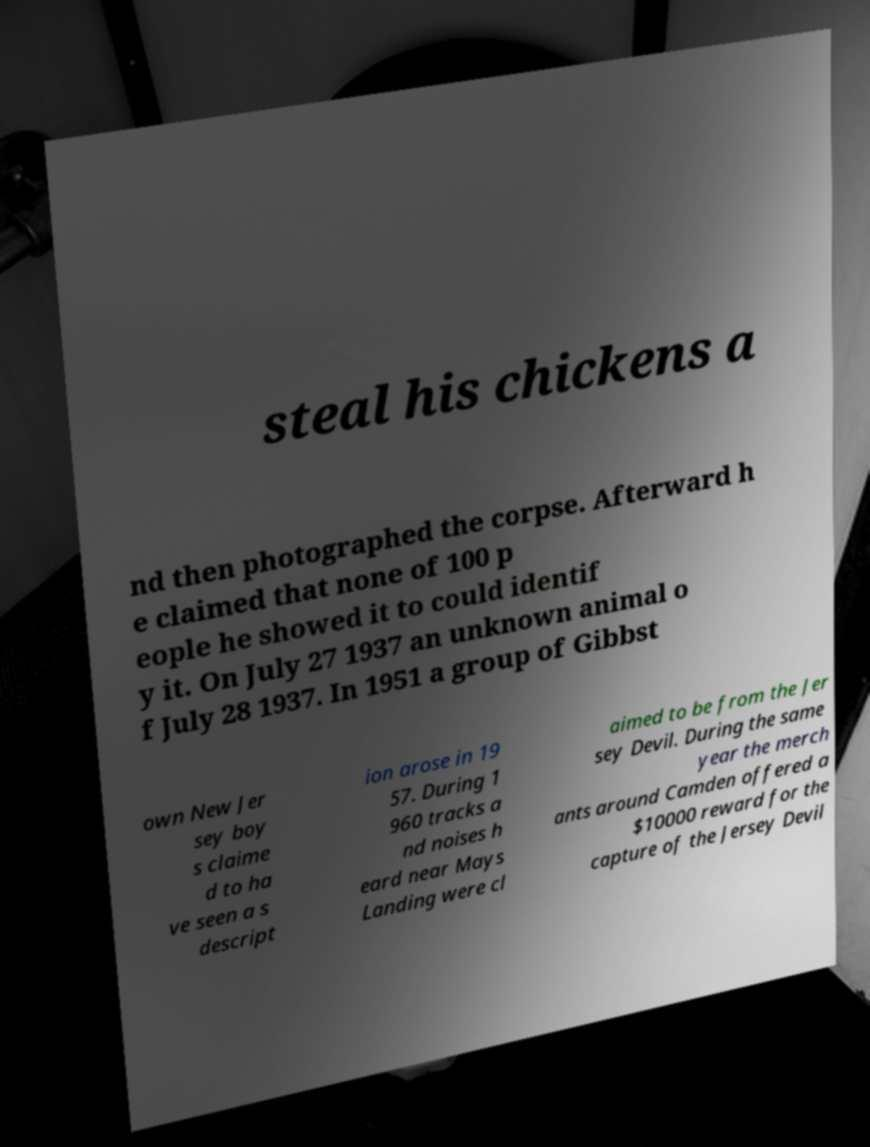Can you accurately transcribe the text from the provided image for me? steal his chickens a nd then photographed the corpse. Afterward h e claimed that none of 100 p eople he showed it to could identif y it. On July 27 1937 an unknown animal o f July 28 1937. In 1951 a group of Gibbst own New Jer sey boy s claime d to ha ve seen a s descript ion arose in 19 57. During 1 960 tracks a nd noises h eard near Mays Landing were cl aimed to be from the Jer sey Devil. During the same year the merch ants around Camden offered a $10000 reward for the capture of the Jersey Devil 